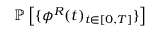Convert formula to latex. <formula><loc_0><loc_0><loc_500><loc_500>\mathbb { P } \left [ \{ \phi ^ { R } ( t ) _ { t \in [ 0 , T ] } \} \right ]</formula> 